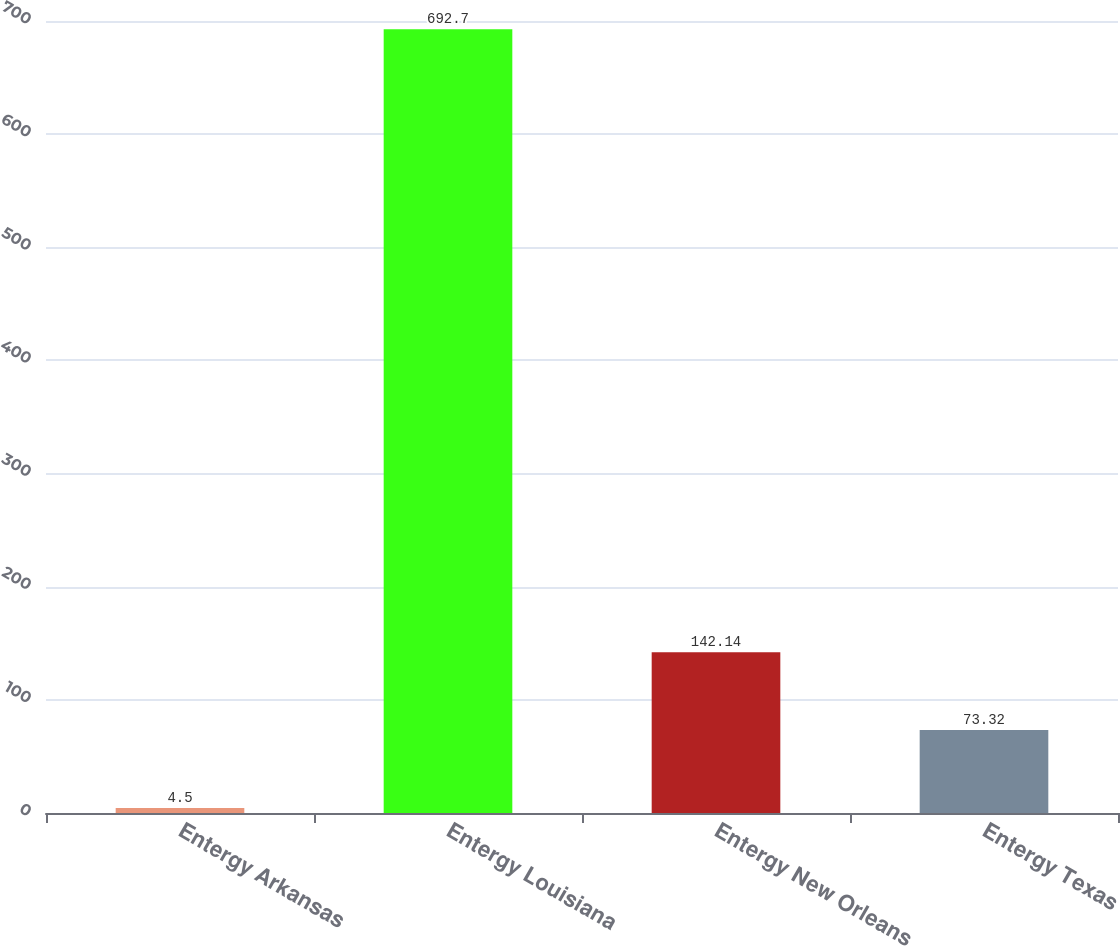Convert chart to OTSL. <chart><loc_0><loc_0><loc_500><loc_500><bar_chart><fcel>Entergy Arkansas<fcel>Entergy Louisiana<fcel>Entergy New Orleans<fcel>Entergy Texas<nl><fcel>4.5<fcel>692.7<fcel>142.14<fcel>73.32<nl></chart> 